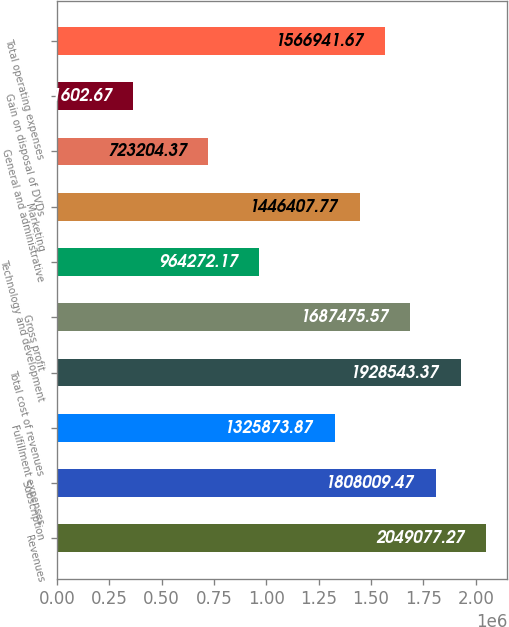Convert chart to OTSL. <chart><loc_0><loc_0><loc_500><loc_500><bar_chart><fcel>Revenues<fcel>Subscription<fcel>Fulfillment expenses<fcel>Total cost of revenues<fcel>Gross profit<fcel>Technology and development<fcel>Marketing<fcel>General and administrative<fcel>Gain on disposal of DVDs<fcel>Total operating expenses<nl><fcel>2.04908e+06<fcel>1.80801e+06<fcel>1.32587e+06<fcel>1.92854e+06<fcel>1.68748e+06<fcel>964272<fcel>1.44641e+06<fcel>723204<fcel>361603<fcel>1.56694e+06<nl></chart> 